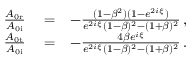<formula> <loc_0><loc_0><loc_500><loc_500>\begin{array} { r l r } { \frac { A _ { 0 r } } { A _ { 0 i } } } & = } & { - \frac { ( 1 - \beta ^ { 2 } ) ( 1 - e ^ { 2 i \xi } ) } { e ^ { 2 i \xi } ( 1 - \beta ) ^ { 2 } - ( 1 + \beta ) ^ { 2 } } \, , } \\ { \frac { A _ { 0 t } } { A _ { 0 i } } } & = } & { - \frac { 4 \beta e ^ { i \xi } } { e ^ { 2 i \xi } ( 1 - \beta ) ^ { 2 } - ( 1 + \beta ) ^ { 2 } } \, . } \end{array}</formula> 